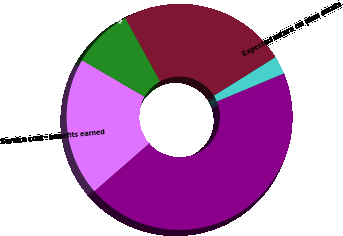<chart> <loc_0><loc_0><loc_500><loc_500><pie_chart><fcel>Service cost - benefits earned<fcel>Interest cost on projected<fcel>Expected return on plan assets<fcel>Amortization of prior service<fcel>Amortization of net loss<nl><fcel>19.84%<fcel>44.87%<fcel>2.59%<fcel>24.07%<fcel>8.63%<nl></chart> 